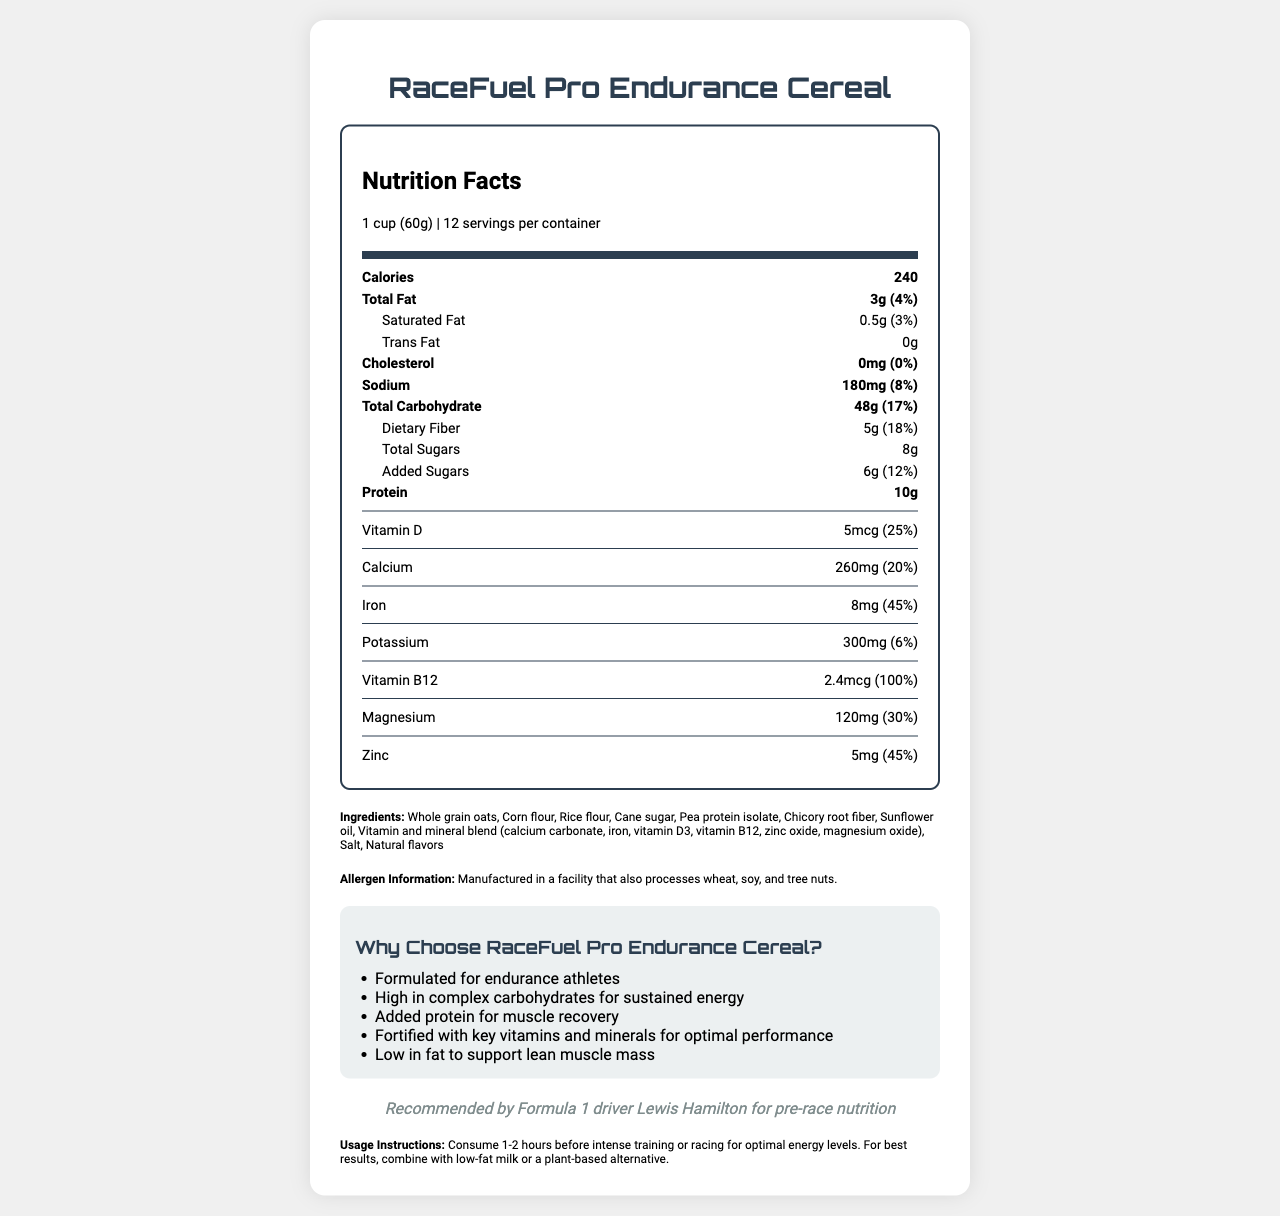What is the product name of the cereal? The product name is clearly mentioned at the beginning of the document as "RaceFuel Pro Endurance Cereal."
Answer: RaceFuel Pro Endurance Cereal What is the serving size of RaceFuel Pro Endurance Cereal? The serving size is listed under the nutrition facts header and specified as "1 cup (60g)."
Answer: 1 cup (60g) How many servings are there per container? The number of servings per container is given in the serving info, which states "12 servings per container."
Answer: 12 How many calories are in one serving of the cereal? The number of calories per serving is specified in the nutrition label section as "240."
Answer: 240 How much protein does one serving contain? Protein amount per serving is mentioned in the nutrition facts as "10g."
Answer: 10g How much Vitamin D does one serving provide, and what is its daily value percentage? The amount of Vitamin D and its daily value percentage are indicated in the vitamins section: "5mcg (25% daily value)."
Answer: 5mcg, 25% daily value Which Formula 1 driver endorses the cereal? A. Fernando Alonso B. Lewis Hamilton C. Sebastian Vettel The athlete endorsement section states: "Recommended by Formula 1 driver Lewis Hamilton for pre-race nutrition."
Answer: B. Lewis Hamilton According to the usage instructions, when should the cereal be consumed for optimal energy levels? A. Right before the race B. During the race C. 1-2 hours before intense training or racing The usage instructions recommend consuming the cereal "1-2 hours before intense training or racing for optimal energy levels."
Answer: C. 1-2 hours before intense training or racing Is the cereal low in fat? One of the marketing claims states: "Low in fat to support lean muscle mass."
Answer: Yes What are the main ingredients of RaceFuel Pro Endurance Cereal? The ingredients section lists all the main ingredients used in the cereal.
Answer: Whole grain oats, Corn flour, Rice flour, Cane sugar, Pea protein isolate, Chicory root fiber, Sunflower oil, Vitamin and mineral blend, Salt, Natural flavors Does the cereal contain any allergens? The allergen information indicates that the cereal is "manufactured in a facility that also processes wheat, soy, and tree nuts."
Answer: Yes Summarize the main purpose and features of RaceFuel Pro Endurance Cereal. The summary covers the main aspects of the cereal, including its target consumers (endurance athletes), key nutritional benefits, athlete endorsement, and special features.
Answer: RaceFuel Pro Endurance Cereal is specifically formulated for endurance athletes' nutritional needs. It provides high energy, added protein for muscle recovery, and is fortified with essential vitamins and minerals. It is recommended by Formula 1 driver Lewis Hamilton and is low in fat to support lean muscle mass. Why does Lewis Hamilton recommend this cereal for pre-race nutrition? The document states that Lewis Hamilton recommends the cereal but does not provide specific reasons for his endorsement.
Answer: Not enough information 